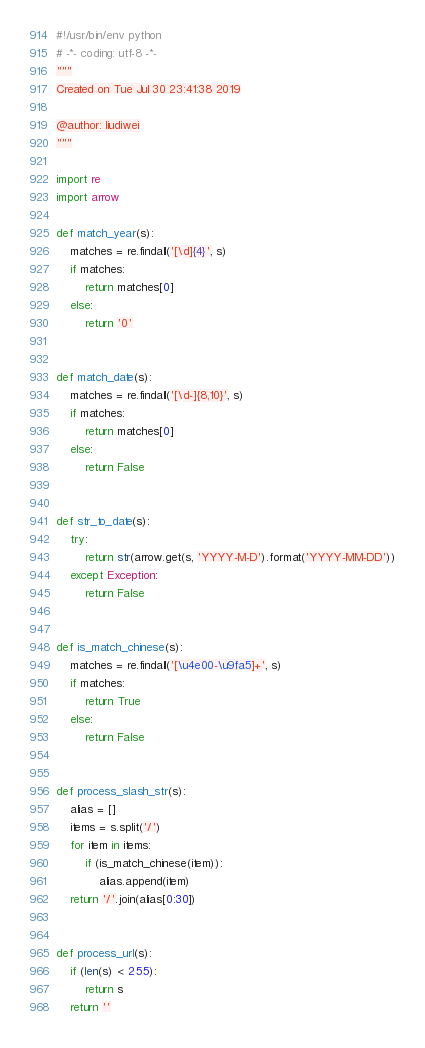Convert code to text. <code><loc_0><loc_0><loc_500><loc_500><_Python_>#!/usr/bin/env python
# -*- coding: utf-8 -*-
"""
Created on Tue Jul 30 23:41:38 2019

@author: liudiwei
"""

import re
import arrow

def match_year(s):
    matches = re.findall('[\d]{4}', s)
    if matches:
        return matches[0]
    else:
        return '0'


def match_date(s):
    matches = re.findall('[\d-]{8,10}', s)
    if matches:
        return matches[0]
    else:
        return False


def str_to_date(s):
    try:
        return str(arrow.get(s, 'YYYY-M-D').format('YYYY-MM-DD'))
    except Exception:
        return False


def is_match_chinese(s):
    matches = re.findall('[\u4e00-\u9fa5]+', s)
    if matches:
        return True
    else:
        return False


def process_slash_str(s):
    alias = []
    items = s.split('/')
    for item in items:
        if (is_match_chinese(item)):
            alias.append(item)
    return '/'.join(alias[0:30])


def process_url(s):
    if (len(s) < 255):
        return s
    return ''
</code> 